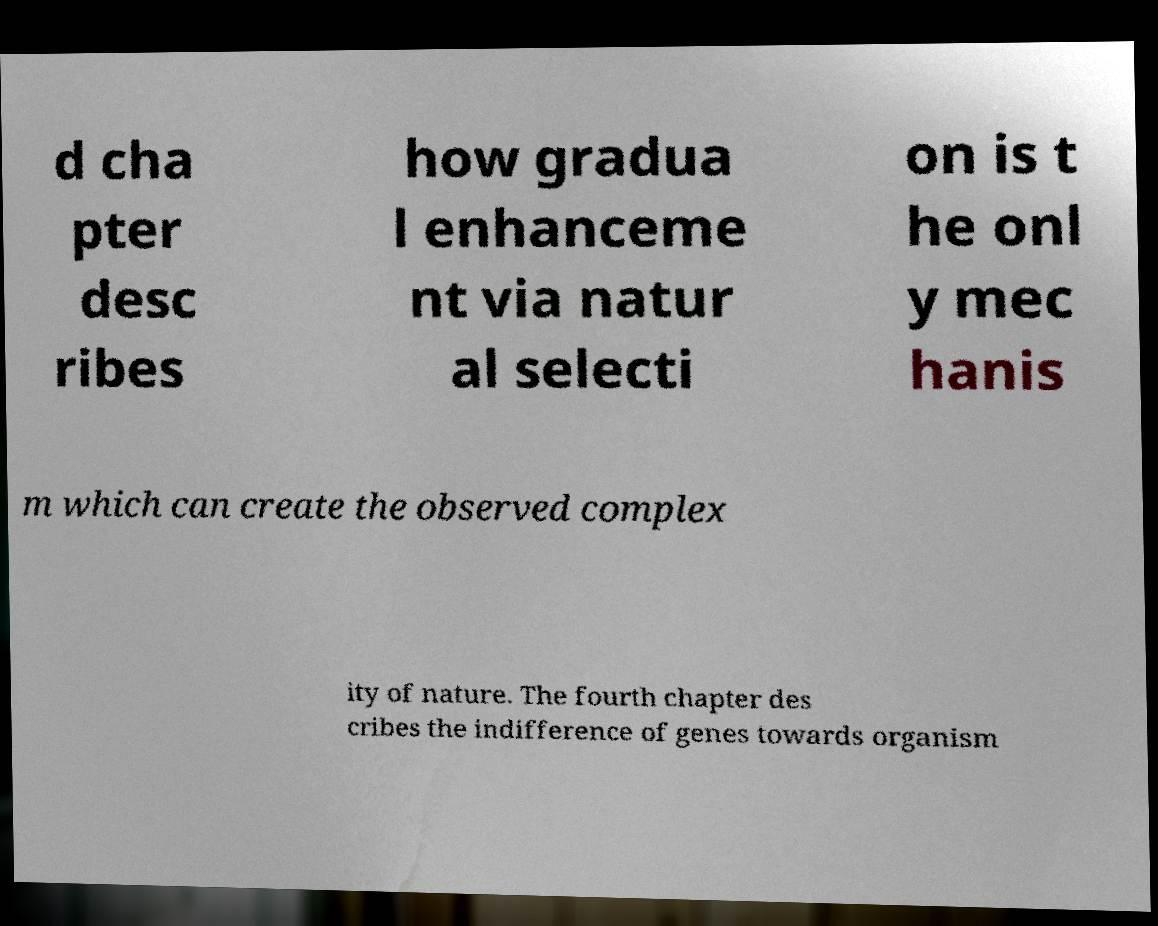Can you read and provide the text displayed in the image?This photo seems to have some interesting text. Can you extract and type it out for me? d cha pter desc ribes how gradua l enhanceme nt via natur al selecti on is t he onl y mec hanis m which can create the observed complex ity of nature. The fourth chapter des cribes the indifference of genes towards organism 